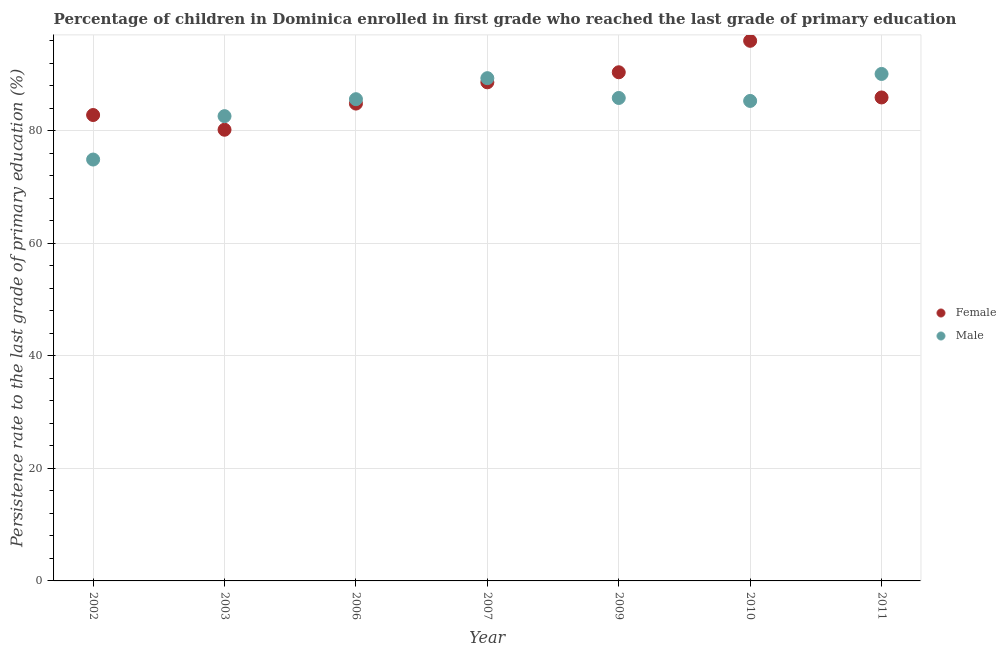How many different coloured dotlines are there?
Make the answer very short. 2. Is the number of dotlines equal to the number of legend labels?
Your answer should be very brief. Yes. What is the persistence rate of male students in 2002?
Ensure brevity in your answer.  74.88. Across all years, what is the maximum persistence rate of male students?
Your answer should be compact. 90.09. Across all years, what is the minimum persistence rate of female students?
Give a very brief answer. 80.17. What is the total persistence rate of male students in the graph?
Provide a short and direct response. 593.61. What is the difference between the persistence rate of female students in 2002 and that in 2003?
Your answer should be compact. 2.62. What is the difference between the persistence rate of male students in 2011 and the persistence rate of female students in 2002?
Provide a succinct answer. 7.3. What is the average persistence rate of male students per year?
Provide a short and direct response. 84.8. In the year 2006, what is the difference between the persistence rate of male students and persistence rate of female students?
Provide a succinct answer. 0.78. In how many years, is the persistence rate of male students greater than 44 %?
Give a very brief answer. 7. What is the ratio of the persistence rate of male students in 2003 to that in 2007?
Your response must be concise. 0.92. Is the persistence rate of male students in 2010 less than that in 2011?
Your answer should be very brief. Yes. Is the difference between the persistence rate of male students in 2002 and 2007 greater than the difference between the persistence rate of female students in 2002 and 2007?
Keep it short and to the point. No. What is the difference between the highest and the second highest persistence rate of female students?
Ensure brevity in your answer.  5.59. What is the difference between the highest and the lowest persistence rate of female students?
Keep it short and to the point. 15.8. In how many years, is the persistence rate of male students greater than the average persistence rate of male students taken over all years?
Offer a terse response. 5. Is the persistence rate of male students strictly greater than the persistence rate of female students over the years?
Give a very brief answer. No. How many dotlines are there?
Offer a terse response. 2. How many years are there in the graph?
Your response must be concise. 7. Are the values on the major ticks of Y-axis written in scientific E-notation?
Keep it short and to the point. No. Where does the legend appear in the graph?
Make the answer very short. Center right. How are the legend labels stacked?
Your answer should be compact. Vertical. What is the title of the graph?
Give a very brief answer. Percentage of children in Dominica enrolled in first grade who reached the last grade of primary education. Does "All education staff compensation" appear as one of the legend labels in the graph?
Ensure brevity in your answer.  No. What is the label or title of the X-axis?
Ensure brevity in your answer.  Year. What is the label or title of the Y-axis?
Provide a succinct answer. Persistence rate to the last grade of primary education (%). What is the Persistence rate to the last grade of primary education (%) in Female in 2002?
Your answer should be very brief. 82.79. What is the Persistence rate to the last grade of primary education (%) in Male in 2002?
Your answer should be very brief. 74.88. What is the Persistence rate to the last grade of primary education (%) of Female in 2003?
Ensure brevity in your answer.  80.17. What is the Persistence rate to the last grade of primary education (%) in Male in 2003?
Your answer should be very brief. 82.59. What is the Persistence rate to the last grade of primary education (%) of Female in 2006?
Give a very brief answer. 84.82. What is the Persistence rate to the last grade of primary education (%) of Male in 2006?
Provide a succinct answer. 85.6. What is the Persistence rate to the last grade of primary education (%) in Female in 2007?
Offer a terse response. 88.6. What is the Persistence rate to the last grade of primary education (%) in Male in 2007?
Your answer should be very brief. 89.34. What is the Persistence rate to the last grade of primary education (%) of Female in 2009?
Give a very brief answer. 90.39. What is the Persistence rate to the last grade of primary education (%) in Male in 2009?
Make the answer very short. 85.82. What is the Persistence rate to the last grade of primary education (%) of Female in 2010?
Offer a terse response. 95.98. What is the Persistence rate to the last grade of primary education (%) of Male in 2010?
Ensure brevity in your answer.  85.29. What is the Persistence rate to the last grade of primary education (%) of Female in 2011?
Provide a succinct answer. 85.91. What is the Persistence rate to the last grade of primary education (%) in Male in 2011?
Provide a short and direct response. 90.09. Across all years, what is the maximum Persistence rate to the last grade of primary education (%) of Female?
Your response must be concise. 95.98. Across all years, what is the maximum Persistence rate to the last grade of primary education (%) of Male?
Your answer should be very brief. 90.09. Across all years, what is the minimum Persistence rate to the last grade of primary education (%) of Female?
Your answer should be compact. 80.17. Across all years, what is the minimum Persistence rate to the last grade of primary education (%) of Male?
Offer a very short reply. 74.88. What is the total Persistence rate to the last grade of primary education (%) in Female in the graph?
Offer a very short reply. 608.66. What is the total Persistence rate to the last grade of primary education (%) in Male in the graph?
Provide a short and direct response. 593.61. What is the difference between the Persistence rate to the last grade of primary education (%) of Female in 2002 and that in 2003?
Offer a very short reply. 2.62. What is the difference between the Persistence rate to the last grade of primary education (%) in Male in 2002 and that in 2003?
Provide a succinct answer. -7.71. What is the difference between the Persistence rate to the last grade of primary education (%) of Female in 2002 and that in 2006?
Your answer should be very brief. -2.03. What is the difference between the Persistence rate to the last grade of primary education (%) in Male in 2002 and that in 2006?
Your answer should be very brief. -10.72. What is the difference between the Persistence rate to the last grade of primary education (%) in Female in 2002 and that in 2007?
Make the answer very short. -5.81. What is the difference between the Persistence rate to the last grade of primary education (%) in Male in 2002 and that in 2007?
Give a very brief answer. -14.46. What is the difference between the Persistence rate to the last grade of primary education (%) in Female in 2002 and that in 2009?
Offer a very short reply. -7.6. What is the difference between the Persistence rate to the last grade of primary education (%) in Male in 2002 and that in 2009?
Provide a short and direct response. -10.94. What is the difference between the Persistence rate to the last grade of primary education (%) in Female in 2002 and that in 2010?
Keep it short and to the point. -13.19. What is the difference between the Persistence rate to the last grade of primary education (%) in Male in 2002 and that in 2010?
Ensure brevity in your answer.  -10.41. What is the difference between the Persistence rate to the last grade of primary education (%) of Female in 2002 and that in 2011?
Ensure brevity in your answer.  -3.12. What is the difference between the Persistence rate to the last grade of primary education (%) in Male in 2002 and that in 2011?
Offer a terse response. -15.21. What is the difference between the Persistence rate to the last grade of primary education (%) in Female in 2003 and that in 2006?
Your response must be concise. -4.65. What is the difference between the Persistence rate to the last grade of primary education (%) of Male in 2003 and that in 2006?
Keep it short and to the point. -3.01. What is the difference between the Persistence rate to the last grade of primary education (%) in Female in 2003 and that in 2007?
Give a very brief answer. -8.43. What is the difference between the Persistence rate to the last grade of primary education (%) of Male in 2003 and that in 2007?
Your answer should be compact. -6.75. What is the difference between the Persistence rate to the last grade of primary education (%) in Female in 2003 and that in 2009?
Your response must be concise. -10.21. What is the difference between the Persistence rate to the last grade of primary education (%) in Male in 2003 and that in 2009?
Ensure brevity in your answer.  -3.23. What is the difference between the Persistence rate to the last grade of primary education (%) in Female in 2003 and that in 2010?
Offer a very short reply. -15.8. What is the difference between the Persistence rate to the last grade of primary education (%) in Male in 2003 and that in 2010?
Provide a succinct answer. -2.7. What is the difference between the Persistence rate to the last grade of primary education (%) of Female in 2003 and that in 2011?
Provide a succinct answer. -5.74. What is the difference between the Persistence rate to the last grade of primary education (%) in Male in 2003 and that in 2011?
Your answer should be compact. -7.5. What is the difference between the Persistence rate to the last grade of primary education (%) in Female in 2006 and that in 2007?
Keep it short and to the point. -3.78. What is the difference between the Persistence rate to the last grade of primary education (%) in Male in 2006 and that in 2007?
Offer a terse response. -3.74. What is the difference between the Persistence rate to the last grade of primary education (%) of Female in 2006 and that in 2009?
Give a very brief answer. -5.56. What is the difference between the Persistence rate to the last grade of primary education (%) of Male in 2006 and that in 2009?
Keep it short and to the point. -0.22. What is the difference between the Persistence rate to the last grade of primary education (%) of Female in 2006 and that in 2010?
Provide a short and direct response. -11.15. What is the difference between the Persistence rate to the last grade of primary education (%) of Male in 2006 and that in 2010?
Ensure brevity in your answer.  0.31. What is the difference between the Persistence rate to the last grade of primary education (%) of Female in 2006 and that in 2011?
Give a very brief answer. -1.09. What is the difference between the Persistence rate to the last grade of primary education (%) of Male in 2006 and that in 2011?
Your response must be concise. -4.49. What is the difference between the Persistence rate to the last grade of primary education (%) in Female in 2007 and that in 2009?
Your answer should be compact. -1.79. What is the difference between the Persistence rate to the last grade of primary education (%) in Male in 2007 and that in 2009?
Your answer should be compact. 3.52. What is the difference between the Persistence rate to the last grade of primary education (%) of Female in 2007 and that in 2010?
Keep it short and to the point. -7.38. What is the difference between the Persistence rate to the last grade of primary education (%) in Male in 2007 and that in 2010?
Provide a short and direct response. 4.05. What is the difference between the Persistence rate to the last grade of primary education (%) in Female in 2007 and that in 2011?
Give a very brief answer. 2.69. What is the difference between the Persistence rate to the last grade of primary education (%) in Male in 2007 and that in 2011?
Keep it short and to the point. -0.75. What is the difference between the Persistence rate to the last grade of primary education (%) in Female in 2009 and that in 2010?
Provide a succinct answer. -5.59. What is the difference between the Persistence rate to the last grade of primary education (%) in Male in 2009 and that in 2010?
Provide a short and direct response. 0.53. What is the difference between the Persistence rate to the last grade of primary education (%) in Female in 2009 and that in 2011?
Give a very brief answer. 4.48. What is the difference between the Persistence rate to the last grade of primary education (%) in Male in 2009 and that in 2011?
Offer a terse response. -4.27. What is the difference between the Persistence rate to the last grade of primary education (%) of Female in 2010 and that in 2011?
Provide a short and direct response. 10.07. What is the difference between the Persistence rate to the last grade of primary education (%) of Male in 2010 and that in 2011?
Provide a short and direct response. -4.79. What is the difference between the Persistence rate to the last grade of primary education (%) in Female in 2002 and the Persistence rate to the last grade of primary education (%) in Male in 2003?
Make the answer very short. 0.2. What is the difference between the Persistence rate to the last grade of primary education (%) in Female in 2002 and the Persistence rate to the last grade of primary education (%) in Male in 2006?
Provide a short and direct response. -2.81. What is the difference between the Persistence rate to the last grade of primary education (%) of Female in 2002 and the Persistence rate to the last grade of primary education (%) of Male in 2007?
Your answer should be very brief. -6.55. What is the difference between the Persistence rate to the last grade of primary education (%) in Female in 2002 and the Persistence rate to the last grade of primary education (%) in Male in 2009?
Provide a short and direct response. -3.03. What is the difference between the Persistence rate to the last grade of primary education (%) of Female in 2002 and the Persistence rate to the last grade of primary education (%) of Male in 2010?
Your answer should be very brief. -2.5. What is the difference between the Persistence rate to the last grade of primary education (%) in Female in 2002 and the Persistence rate to the last grade of primary education (%) in Male in 2011?
Provide a succinct answer. -7.3. What is the difference between the Persistence rate to the last grade of primary education (%) of Female in 2003 and the Persistence rate to the last grade of primary education (%) of Male in 2006?
Your response must be concise. -5.43. What is the difference between the Persistence rate to the last grade of primary education (%) in Female in 2003 and the Persistence rate to the last grade of primary education (%) in Male in 2007?
Ensure brevity in your answer.  -9.17. What is the difference between the Persistence rate to the last grade of primary education (%) of Female in 2003 and the Persistence rate to the last grade of primary education (%) of Male in 2009?
Provide a short and direct response. -5.65. What is the difference between the Persistence rate to the last grade of primary education (%) in Female in 2003 and the Persistence rate to the last grade of primary education (%) in Male in 2010?
Provide a succinct answer. -5.12. What is the difference between the Persistence rate to the last grade of primary education (%) in Female in 2003 and the Persistence rate to the last grade of primary education (%) in Male in 2011?
Offer a very short reply. -9.91. What is the difference between the Persistence rate to the last grade of primary education (%) in Female in 2006 and the Persistence rate to the last grade of primary education (%) in Male in 2007?
Make the answer very short. -4.52. What is the difference between the Persistence rate to the last grade of primary education (%) in Female in 2006 and the Persistence rate to the last grade of primary education (%) in Male in 2009?
Provide a succinct answer. -1. What is the difference between the Persistence rate to the last grade of primary education (%) of Female in 2006 and the Persistence rate to the last grade of primary education (%) of Male in 2010?
Your response must be concise. -0.47. What is the difference between the Persistence rate to the last grade of primary education (%) in Female in 2006 and the Persistence rate to the last grade of primary education (%) in Male in 2011?
Your answer should be very brief. -5.27. What is the difference between the Persistence rate to the last grade of primary education (%) in Female in 2007 and the Persistence rate to the last grade of primary education (%) in Male in 2009?
Your response must be concise. 2.78. What is the difference between the Persistence rate to the last grade of primary education (%) of Female in 2007 and the Persistence rate to the last grade of primary education (%) of Male in 2010?
Provide a short and direct response. 3.31. What is the difference between the Persistence rate to the last grade of primary education (%) in Female in 2007 and the Persistence rate to the last grade of primary education (%) in Male in 2011?
Offer a very short reply. -1.49. What is the difference between the Persistence rate to the last grade of primary education (%) in Female in 2009 and the Persistence rate to the last grade of primary education (%) in Male in 2010?
Ensure brevity in your answer.  5.09. What is the difference between the Persistence rate to the last grade of primary education (%) of Female in 2009 and the Persistence rate to the last grade of primary education (%) of Male in 2011?
Offer a terse response. 0.3. What is the difference between the Persistence rate to the last grade of primary education (%) of Female in 2010 and the Persistence rate to the last grade of primary education (%) of Male in 2011?
Your answer should be very brief. 5.89. What is the average Persistence rate to the last grade of primary education (%) in Female per year?
Offer a terse response. 86.95. What is the average Persistence rate to the last grade of primary education (%) of Male per year?
Make the answer very short. 84.8. In the year 2002, what is the difference between the Persistence rate to the last grade of primary education (%) in Female and Persistence rate to the last grade of primary education (%) in Male?
Keep it short and to the point. 7.91. In the year 2003, what is the difference between the Persistence rate to the last grade of primary education (%) of Female and Persistence rate to the last grade of primary education (%) of Male?
Offer a terse response. -2.41. In the year 2006, what is the difference between the Persistence rate to the last grade of primary education (%) in Female and Persistence rate to the last grade of primary education (%) in Male?
Provide a succinct answer. -0.78. In the year 2007, what is the difference between the Persistence rate to the last grade of primary education (%) in Female and Persistence rate to the last grade of primary education (%) in Male?
Keep it short and to the point. -0.74. In the year 2009, what is the difference between the Persistence rate to the last grade of primary education (%) of Female and Persistence rate to the last grade of primary education (%) of Male?
Ensure brevity in your answer.  4.57. In the year 2010, what is the difference between the Persistence rate to the last grade of primary education (%) in Female and Persistence rate to the last grade of primary education (%) in Male?
Your response must be concise. 10.68. In the year 2011, what is the difference between the Persistence rate to the last grade of primary education (%) of Female and Persistence rate to the last grade of primary education (%) of Male?
Offer a terse response. -4.18. What is the ratio of the Persistence rate to the last grade of primary education (%) of Female in 2002 to that in 2003?
Offer a terse response. 1.03. What is the ratio of the Persistence rate to the last grade of primary education (%) of Male in 2002 to that in 2003?
Give a very brief answer. 0.91. What is the ratio of the Persistence rate to the last grade of primary education (%) in Male in 2002 to that in 2006?
Provide a short and direct response. 0.87. What is the ratio of the Persistence rate to the last grade of primary education (%) in Female in 2002 to that in 2007?
Ensure brevity in your answer.  0.93. What is the ratio of the Persistence rate to the last grade of primary education (%) in Male in 2002 to that in 2007?
Your response must be concise. 0.84. What is the ratio of the Persistence rate to the last grade of primary education (%) in Female in 2002 to that in 2009?
Your answer should be very brief. 0.92. What is the ratio of the Persistence rate to the last grade of primary education (%) in Male in 2002 to that in 2009?
Give a very brief answer. 0.87. What is the ratio of the Persistence rate to the last grade of primary education (%) of Female in 2002 to that in 2010?
Provide a succinct answer. 0.86. What is the ratio of the Persistence rate to the last grade of primary education (%) of Male in 2002 to that in 2010?
Give a very brief answer. 0.88. What is the ratio of the Persistence rate to the last grade of primary education (%) in Female in 2002 to that in 2011?
Keep it short and to the point. 0.96. What is the ratio of the Persistence rate to the last grade of primary education (%) of Male in 2002 to that in 2011?
Keep it short and to the point. 0.83. What is the ratio of the Persistence rate to the last grade of primary education (%) in Female in 2003 to that in 2006?
Offer a very short reply. 0.95. What is the ratio of the Persistence rate to the last grade of primary education (%) of Male in 2003 to that in 2006?
Your answer should be very brief. 0.96. What is the ratio of the Persistence rate to the last grade of primary education (%) of Female in 2003 to that in 2007?
Offer a very short reply. 0.9. What is the ratio of the Persistence rate to the last grade of primary education (%) in Male in 2003 to that in 2007?
Provide a succinct answer. 0.92. What is the ratio of the Persistence rate to the last grade of primary education (%) in Female in 2003 to that in 2009?
Offer a very short reply. 0.89. What is the ratio of the Persistence rate to the last grade of primary education (%) in Male in 2003 to that in 2009?
Your response must be concise. 0.96. What is the ratio of the Persistence rate to the last grade of primary education (%) of Female in 2003 to that in 2010?
Make the answer very short. 0.84. What is the ratio of the Persistence rate to the last grade of primary education (%) of Male in 2003 to that in 2010?
Your response must be concise. 0.97. What is the ratio of the Persistence rate to the last grade of primary education (%) in Female in 2003 to that in 2011?
Provide a short and direct response. 0.93. What is the ratio of the Persistence rate to the last grade of primary education (%) in Male in 2003 to that in 2011?
Make the answer very short. 0.92. What is the ratio of the Persistence rate to the last grade of primary education (%) in Female in 2006 to that in 2007?
Your answer should be compact. 0.96. What is the ratio of the Persistence rate to the last grade of primary education (%) in Male in 2006 to that in 2007?
Provide a short and direct response. 0.96. What is the ratio of the Persistence rate to the last grade of primary education (%) of Female in 2006 to that in 2009?
Provide a short and direct response. 0.94. What is the ratio of the Persistence rate to the last grade of primary education (%) of Female in 2006 to that in 2010?
Your response must be concise. 0.88. What is the ratio of the Persistence rate to the last grade of primary education (%) of Male in 2006 to that in 2010?
Your response must be concise. 1. What is the ratio of the Persistence rate to the last grade of primary education (%) in Female in 2006 to that in 2011?
Offer a very short reply. 0.99. What is the ratio of the Persistence rate to the last grade of primary education (%) in Male in 2006 to that in 2011?
Your response must be concise. 0.95. What is the ratio of the Persistence rate to the last grade of primary education (%) in Female in 2007 to that in 2009?
Give a very brief answer. 0.98. What is the ratio of the Persistence rate to the last grade of primary education (%) in Male in 2007 to that in 2009?
Make the answer very short. 1.04. What is the ratio of the Persistence rate to the last grade of primary education (%) in Female in 2007 to that in 2010?
Provide a succinct answer. 0.92. What is the ratio of the Persistence rate to the last grade of primary education (%) in Male in 2007 to that in 2010?
Your answer should be compact. 1.05. What is the ratio of the Persistence rate to the last grade of primary education (%) in Female in 2007 to that in 2011?
Ensure brevity in your answer.  1.03. What is the ratio of the Persistence rate to the last grade of primary education (%) in Male in 2007 to that in 2011?
Your answer should be very brief. 0.99. What is the ratio of the Persistence rate to the last grade of primary education (%) of Female in 2009 to that in 2010?
Your response must be concise. 0.94. What is the ratio of the Persistence rate to the last grade of primary education (%) in Male in 2009 to that in 2010?
Give a very brief answer. 1.01. What is the ratio of the Persistence rate to the last grade of primary education (%) in Female in 2009 to that in 2011?
Your answer should be very brief. 1.05. What is the ratio of the Persistence rate to the last grade of primary education (%) of Male in 2009 to that in 2011?
Your answer should be very brief. 0.95. What is the ratio of the Persistence rate to the last grade of primary education (%) of Female in 2010 to that in 2011?
Provide a succinct answer. 1.12. What is the ratio of the Persistence rate to the last grade of primary education (%) of Male in 2010 to that in 2011?
Provide a short and direct response. 0.95. What is the difference between the highest and the second highest Persistence rate to the last grade of primary education (%) of Female?
Provide a succinct answer. 5.59. What is the difference between the highest and the second highest Persistence rate to the last grade of primary education (%) in Male?
Ensure brevity in your answer.  0.75. What is the difference between the highest and the lowest Persistence rate to the last grade of primary education (%) of Female?
Give a very brief answer. 15.8. What is the difference between the highest and the lowest Persistence rate to the last grade of primary education (%) of Male?
Your answer should be very brief. 15.21. 